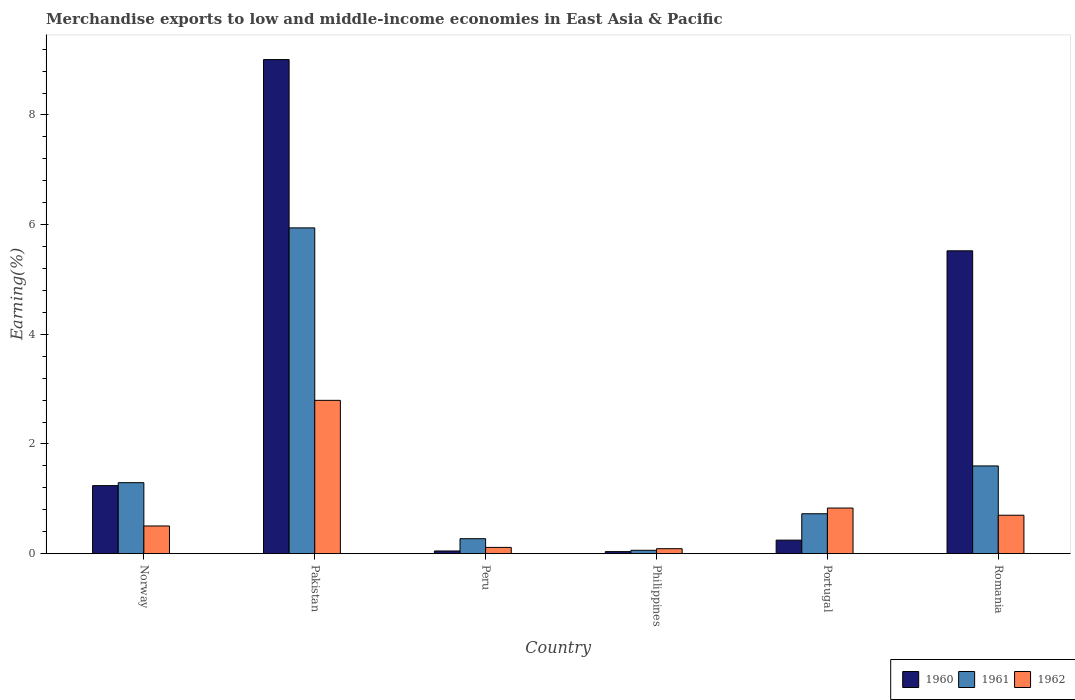How many different coloured bars are there?
Offer a terse response. 3. Are the number of bars per tick equal to the number of legend labels?
Your response must be concise. Yes. Are the number of bars on each tick of the X-axis equal?
Your answer should be very brief. Yes. What is the percentage of amount earned from merchandise exports in 1960 in Norway?
Provide a short and direct response. 1.24. Across all countries, what is the maximum percentage of amount earned from merchandise exports in 1961?
Offer a terse response. 5.94. Across all countries, what is the minimum percentage of amount earned from merchandise exports in 1960?
Keep it short and to the point. 0.04. What is the total percentage of amount earned from merchandise exports in 1961 in the graph?
Ensure brevity in your answer.  9.9. What is the difference between the percentage of amount earned from merchandise exports in 1960 in Norway and that in Portugal?
Make the answer very short. 0.99. What is the difference between the percentage of amount earned from merchandise exports in 1962 in Norway and the percentage of amount earned from merchandise exports in 1960 in Pakistan?
Your response must be concise. -8.5. What is the average percentage of amount earned from merchandise exports in 1961 per country?
Your answer should be compact. 1.65. What is the difference between the percentage of amount earned from merchandise exports of/in 1960 and percentage of amount earned from merchandise exports of/in 1961 in Pakistan?
Your answer should be very brief. 3.07. In how many countries, is the percentage of amount earned from merchandise exports in 1962 greater than 3.6 %?
Your answer should be compact. 0. What is the ratio of the percentage of amount earned from merchandise exports in 1961 in Pakistan to that in Philippines?
Your answer should be very brief. 96.53. Is the percentage of amount earned from merchandise exports in 1961 in Norway less than that in Portugal?
Keep it short and to the point. No. What is the difference between the highest and the second highest percentage of amount earned from merchandise exports in 1960?
Ensure brevity in your answer.  3.49. What is the difference between the highest and the lowest percentage of amount earned from merchandise exports in 1962?
Make the answer very short. 2.71. In how many countries, is the percentage of amount earned from merchandise exports in 1961 greater than the average percentage of amount earned from merchandise exports in 1961 taken over all countries?
Offer a very short reply. 1. What does the 2nd bar from the right in Romania represents?
Your response must be concise. 1961. How many bars are there?
Provide a short and direct response. 18. Are all the bars in the graph horizontal?
Ensure brevity in your answer.  No. What is the difference between two consecutive major ticks on the Y-axis?
Offer a terse response. 2. Are the values on the major ticks of Y-axis written in scientific E-notation?
Keep it short and to the point. No. Does the graph contain any zero values?
Provide a short and direct response. No. Does the graph contain grids?
Keep it short and to the point. No. How many legend labels are there?
Your response must be concise. 3. How are the legend labels stacked?
Your response must be concise. Horizontal. What is the title of the graph?
Your answer should be compact. Merchandise exports to low and middle-income economies in East Asia & Pacific. Does "1970" appear as one of the legend labels in the graph?
Your answer should be very brief. No. What is the label or title of the Y-axis?
Your response must be concise. Earning(%). What is the Earning(%) in 1960 in Norway?
Your answer should be very brief. 1.24. What is the Earning(%) in 1961 in Norway?
Ensure brevity in your answer.  1.29. What is the Earning(%) of 1962 in Norway?
Make the answer very short. 0.5. What is the Earning(%) in 1960 in Pakistan?
Offer a very short reply. 9.01. What is the Earning(%) of 1961 in Pakistan?
Offer a terse response. 5.94. What is the Earning(%) of 1962 in Pakistan?
Offer a terse response. 2.8. What is the Earning(%) in 1960 in Peru?
Make the answer very short. 0.05. What is the Earning(%) of 1961 in Peru?
Provide a succinct answer. 0.27. What is the Earning(%) in 1962 in Peru?
Ensure brevity in your answer.  0.11. What is the Earning(%) of 1960 in Philippines?
Provide a succinct answer. 0.04. What is the Earning(%) of 1961 in Philippines?
Offer a very short reply. 0.06. What is the Earning(%) in 1962 in Philippines?
Your response must be concise. 0.09. What is the Earning(%) in 1960 in Portugal?
Your response must be concise. 0.25. What is the Earning(%) in 1961 in Portugal?
Ensure brevity in your answer.  0.73. What is the Earning(%) in 1962 in Portugal?
Keep it short and to the point. 0.83. What is the Earning(%) of 1960 in Romania?
Provide a succinct answer. 5.52. What is the Earning(%) of 1961 in Romania?
Keep it short and to the point. 1.6. What is the Earning(%) in 1962 in Romania?
Your response must be concise. 0.7. Across all countries, what is the maximum Earning(%) of 1960?
Offer a terse response. 9.01. Across all countries, what is the maximum Earning(%) in 1961?
Offer a terse response. 5.94. Across all countries, what is the maximum Earning(%) in 1962?
Offer a very short reply. 2.8. Across all countries, what is the minimum Earning(%) in 1960?
Your answer should be very brief. 0.04. Across all countries, what is the minimum Earning(%) of 1961?
Provide a succinct answer. 0.06. Across all countries, what is the minimum Earning(%) in 1962?
Your answer should be very brief. 0.09. What is the total Earning(%) in 1960 in the graph?
Offer a very short reply. 16.11. What is the total Earning(%) of 1961 in the graph?
Ensure brevity in your answer.  9.9. What is the total Earning(%) of 1962 in the graph?
Keep it short and to the point. 5.04. What is the difference between the Earning(%) in 1960 in Norway and that in Pakistan?
Ensure brevity in your answer.  -7.77. What is the difference between the Earning(%) in 1961 in Norway and that in Pakistan?
Keep it short and to the point. -4.65. What is the difference between the Earning(%) of 1962 in Norway and that in Pakistan?
Offer a terse response. -2.29. What is the difference between the Earning(%) in 1960 in Norway and that in Peru?
Keep it short and to the point. 1.19. What is the difference between the Earning(%) in 1961 in Norway and that in Peru?
Offer a terse response. 1.02. What is the difference between the Earning(%) in 1962 in Norway and that in Peru?
Provide a succinct answer. 0.39. What is the difference between the Earning(%) of 1960 in Norway and that in Philippines?
Your answer should be very brief. 1.2. What is the difference between the Earning(%) of 1961 in Norway and that in Philippines?
Your response must be concise. 1.23. What is the difference between the Earning(%) in 1962 in Norway and that in Philippines?
Your response must be concise. 0.41. What is the difference between the Earning(%) of 1961 in Norway and that in Portugal?
Ensure brevity in your answer.  0.57. What is the difference between the Earning(%) of 1962 in Norway and that in Portugal?
Offer a very short reply. -0.33. What is the difference between the Earning(%) of 1960 in Norway and that in Romania?
Give a very brief answer. -4.28. What is the difference between the Earning(%) in 1961 in Norway and that in Romania?
Provide a short and direct response. -0.31. What is the difference between the Earning(%) in 1962 in Norway and that in Romania?
Your answer should be compact. -0.2. What is the difference between the Earning(%) of 1960 in Pakistan and that in Peru?
Give a very brief answer. 8.96. What is the difference between the Earning(%) of 1961 in Pakistan and that in Peru?
Offer a very short reply. 5.67. What is the difference between the Earning(%) in 1962 in Pakistan and that in Peru?
Ensure brevity in your answer.  2.68. What is the difference between the Earning(%) of 1960 in Pakistan and that in Philippines?
Offer a very short reply. 8.97. What is the difference between the Earning(%) in 1961 in Pakistan and that in Philippines?
Your answer should be compact. 5.88. What is the difference between the Earning(%) in 1962 in Pakistan and that in Philippines?
Your answer should be very brief. 2.71. What is the difference between the Earning(%) of 1960 in Pakistan and that in Portugal?
Provide a short and direct response. 8.76. What is the difference between the Earning(%) of 1961 in Pakistan and that in Portugal?
Keep it short and to the point. 5.21. What is the difference between the Earning(%) in 1962 in Pakistan and that in Portugal?
Ensure brevity in your answer.  1.96. What is the difference between the Earning(%) of 1960 in Pakistan and that in Romania?
Make the answer very short. 3.49. What is the difference between the Earning(%) in 1961 in Pakistan and that in Romania?
Your answer should be compact. 4.34. What is the difference between the Earning(%) in 1962 in Pakistan and that in Romania?
Your response must be concise. 2.09. What is the difference between the Earning(%) in 1960 in Peru and that in Philippines?
Make the answer very short. 0.01. What is the difference between the Earning(%) of 1961 in Peru and that in Philippines?
Your answer should be very brief. 0.21. What is the difference between the Earning(%) in 1962 in Peru and that in Philippines?
Ensure brevity in your answer.  0.02. What is the difference between the Earning(%) of 1960 in Peru and that in Portugal?
Your response must be concise. -0.2. What is the difference between the Earning(%) of 1961 in Peru and that in Portugal?
Offer a very short reply. -0.45. What is the difference between the Earning(%) in 1962 in Peru and that in Portugal?
Make the answer very short. -0.72. What is the difference between the Earning(%) in 1960 in Peru and that in Romania?
Offer a terse response. -5.47. What is the difference between the Earning(%) of 1961 in Peru and that in Romania?
Your answer should be compact. -1.33. What is the difference between the Earning(%) in 1962 in Peru and that in Romania?
Provide a short and direct response. -0.59. What is the difference between the Earning(%) in 1960 in Philippines and that in Portugal?
Make the answer very short. -0.21. What is the difference between the Earning(%) of 1961 in Philippines and that in Portugal?
Ensure brevity in your answer.  -0.67. What is the difference between the Earning(%) of 1962 in Philippines and that in Portugal?
Give a very brief answer. -0.74. What is the difference between the Earning(%) in 1960 in Philippines and that in Romania?
Give a very brief answer. -5.49. What is the difference between the Earning(%) in 1961 in Philippines and that in Romania?
Give a very brief answer. -1.54. What is the difference between the Earning(%) in 1962 in Philippines and that in Romania?
Your answer should be very brief. -0.61. What is the difference between the Earning(%) in 1960 in Portugal and that in Romania?
Make the answer very short. -5.28. What is the difference between the Earning(%) of 1961 in Portugal and that in Romania?
Your answer should be very brief. -0.87. What is the difference between the Earning(%) in 1962 in Portugal and that in Romania?
Make the answer very short. 0.13. What is the difference between the Earning(%) of 1960 in Norway and the Earning(%) of 1962 in Pakistan?
Give a very brief answer. -1.56. What is the difference between the Earning(%) of 1961 in Norway and the Earning(%) of 1962 in Pakistan?
Provide a succinct answer. -1.5. What is the difference between the Earning(%) in 1960 in Norway and the Earning(%) in 1962 in Peru?
Offer a very short reply. 1.13. What is the difference between the Earning(%) of 1961 in Norway and the Earning(%) of 1962 in Peru?
Make the answer very short. 1.18. What is the difference between the Earning(%) of 1960 in Norway and the Earning(%) of 1961 in Philippines?
Give a very brief answer. 1.18. What is the difference between the Earning(%) in 1960 in Norway and the Earning(%) in 1962 in Philippines?
Your answer should be very brief. 1.15. What is the difference between the Earning(%) of 1961 in Norway and the Earning(%) of 1962 in Philippines?
Offer a terse response. 1.2. What is the difference between the Earning(%) of 1960 in Norway and the Earning(%) of 1961 in Portugal?
Give a very brief answer. 0.51. What is the difference between the Earning(%) in 1960 in Norway and the Earning(%) in 1962 in Portugal?
Keep it short and to the point. 0.41. What is the difference between the Earning(%) in 1961 in Norway and the Earning(%) in 1962 in Portugal?
Your answer should be compact. 0.46. What is the difference between the Earning(%) in 1960 in Norway and the Earning(%) in 1961 in Romania?
Offer a terse response. -0.36. What is the difference between the Earning(%) of 1960 in Norway and the Earning(%) of 1962 in Romania?
Provide a succinct answer. 0.54. What is the difference between the Earning(%) in 1961 in Norway and the Earning(%) in 1962 in Romania?
Provide a short and direct response. 0.59. What is the difference between the Earning(%) in 1960 in Pakistan and the Earning(%) in 1961 in Peru?
Keep it short and to the point. 8.74. What is the difference between the Earning(%) in 1960 in Pakistan and the Earning(%) in 1962 in Peru?
Keep it short and to the point. 8.9. What is the difference between the Earning(%) of 1961 in Pakistan and the Earning(%) of 1962 in Peru?
Offer a very short reply. 5.83. What is the difference between the Earning(%) of 1960 in Pakistan and the Earning(%) of 1961 in Philippines?
Provide a succinct answer. 8.95. What is the difference between the Earning(%) in 1960 in Pakistan and the Earning(%) in 1962 in Philippines?
Provide a short and direct response. 8.92. What is the difference between the Earning(%) of 1961 in Pakistan and the Earning(%) of 1962 in Philippines?
Offer a terse response. 5.85. What is the difference between the Earning(%) in 1960 in Pakistan and the Earning(%) in 1961 in Portugal?
Your answer should be very brief. 8.28. What is the difference between the Earning(%) in 1960 in Pakistan and the Earning(%) in 1962 in Portugal?
Offer a terse response. 8.18. What is the difference between the Earning(%) of 1961 in Pakistan and the Earning(%) of 1962 in Portugal?
Offer a terse response. 5.11. What is the difference between the Earning(%) of 1960 in Pakistan and the Earning(%) of 1961 in Romania?
Your answer should be very brief. 7.41. What is the difference between the Earning(%) in 1960 in Pakistan and the Earning(%) in 1962 in Romania?
Offer a terse response. 8.31. What is the difference between the Earning(%) in 1961 in Pakistan and the Earning(%) in 1962 in Romania?
Your response must be concise. 5.24. What is the difference between the Earning(%) in 1960 in Peru and the Earning(%) in 1961 in Philippines?
Keep it short and to the point. -0.01. What is the difference between the Earning(%) of 1960 in Peru and the Earning(%) of 1962 in Philippines?
Provide a succinct answer. -0.04. What is the difference between the Earning(%) in 1961 in Peru and the Earning(%) in 1962 in Philippines?
Offer a very short reply. 0.18. What is the difference between the Earning(%) in 1960 in Peru and the Earning(%) in 1961 in Portugal?
Make the answer very short. -0.68. What is the difference between the Earning(%) in 1960 in Peru and the Earning(%) in 1962 in Portugal?
Offer a terse response. -0.78. What is the difference between the Earning(%) of 1961 in Peru and the Earning(%) of 1962 in Portugal?
Keep it short and to the point. -0.56. What is the difference between the Earning(%) in 1960 in Peru and the Earning(%) in 1961 in Romania?
Keep it short and to the point. -1.55. What is the difference between the Earning(%) of 1960 in Peru and the Earning(%) of 1962 in Romania?
Your answer should be very brief. -0.65. What is the difference between the Earning(%) of 1961 in Peru and the Earning(%) of 1962 in Romania?
Offer a terse response. -0.43. What is the difference between the Earning(%) in 1960 in Philippines and the Earning(%) in 1961 in Portugal?
Provide a succinct answer. -0.69. What is the difference between the Earning(%) of 1960 in Philippines and the Earning(%) of 1962 in Portugal?
Offer a terse response. -0.79. What is the difference between the Earning(%) in 1961 in Philippines and the Earning(%) in 1962 in Portugal?
Provide a short and direct response. -0.77. What is the difference between the Earning(%) in 1960 in Philippines and the Earning(%) in 1961 in Romania?
Keep it short and to the point. -1.56. What is the difference between the Earning(%) in 1960 in Philippines and the Earning(%) in 1962 in Romania?
Make the answer very short. -0.66. What is the difference between the Earning(%) in 1961 in Philippines and the Earning(%) in 1962 in Romania?
Ensure brevity in your answer.  -0.64. What is the difference between the Earning(%) of 1960 in Portugal and the Earning(%) of 1961 in Romania?
Your response must be concise. -1.35. What is the difference between the Earning(%) in 1960 in Portugal and the Earning(%) in 1962 in Romania?
Offer a very short reply. -0.45. What is the difference between the Earning(%) of 1961 in Portugal and the Earning(%) of 1962 in Romania?
Your response must be concise. 0.03. What is the average Earning(%) in 1960 per country?
Give a very brief answer. 2.68. What is the average Earning(%) of 1961 per country?
Keep it short and to the point. 1.65. What is the average Earning(%) of 1962 per country?
Your answer should be compact. 0.84. What is the difference between the Earning(%) of 1960 and Earning(%) of 1961 in Norway?
Ensure brevity in your answer.  -0.05. What is the difference between the Earning(%) of 1960 and Earning(%) of 1962 in Norway?
Give a very brief answer. 0.74. What is the difference between the Earning(%) in 1961 and Earning(%) in 1962 in Norway?
Provide a short and direct response. 0.79. What is the difference between the Earning(%) of 1960 and Earning(%) of 1961 in Pakistan?
Your answer should be compact. 3.07. What is the difference between the Earning(%) in 1960 and Earning(%) in 1962 in Pakistan?
Provide a short and direct response. 6.21. What is the difference between the Earning(%) of 1961 and Earning(%) of 1962 in Pakistan?
Your answer should be very brief. 3.14. What is the difference between the Earning(%) in 1960 and Earning(%) in 1961 in Peru?
Your response must be concise. -0.22. What is the difference between the Earning(%) of 1960 and Earning(%) of 1962 in Peru?
Your answer should be compact. -0.07. What is the difference between the Earning(%) of 1961 and Earning(%) of 1962 in Peru?
Offer a very short reply. 0.16. What is the difference between the Earning(%) of 1960 and Earning(%) of 1961 in Philippines?
Make the answer very short. -0.02. What is the difference between the Earning(%) in 1960 and Earning(%) in 1962 in Philippines?
Provide a short and direct response. -0.05. What is the difference between the Earning(%) in 1961 and Earning(%) in 1962 in Philippines?
Your answer should be very brief. -0.03. What is the difference between the Earning(%) in 1960 and Earning(%) in 1961 in Portugal?
Offer a terse response. -0.48. What is the difference between the Earning(%) in 1960 and Earning(%) in 1962 in Portugal?
Make the answer very short. -0.58. What is the difference between the Earning(%) in 1961 and Earning(%) in 1962 in Portugal?
Offer a very short reply. -0.1. What is the difference between the Earning(%) in 1960 and Earning(%) in 1961 in Romania?
Offer a very short reply. 3.92. What is the difference between the Earning(%) of 1960 and Earning(%) of 1962 in Romania?
Give a very brief answer. 4.82. What is the difference between the Earning(%) of 1961 and Earning(%) of 1962 in Romania?
Your answer should be compact. 0.9. What is the ratio of the Earning(%) of 1960 in Norway to that in Pakistan?
Offer a very short reply. 0.14. What is the ratio of the Earning(%) of 1961 in Norway to that in Pakistan?
Provide a succinct answer. 0.22. What is the ratio of the Earning(%) of 1962 in Norway to that in Pakistan?
Keep it short and to the point. 0.18. What is the ratio of the Earning(%) of 1960 in Norway to that in Peru?
Give a very brief answer. 25.36. What is the ratio of the Earning(%) of 1961 in Norway to that in Peru?
Keep it short and to the point. 4.74. What is the ratio of the Earning(%) in 1962 in Norway to that in Peru?
Make the answer very short. 4.42. What is the ratio of the Earning(%) in 1960 in Norway to that in Philippines?
Provide a succinct answer. 33.31. What is the ratio of the Earning(%) in 1961 in Norway to that in Philippines?
Give a very brief answer. 21.03. What is the ratio of the Earning(%) of 1962 in Norway to that in Philippines?
Give a very brief answer. 5.59. What is the ratio of the Earning(%) in 1960 in Norway to that in Portugal?
Your answer should be compact. 5.03. What is the ratio of the Earning(%) of 1961 in Norway to that in Portugal?
Provide a short and direct response. 1.78. What is the ratio of the Earning(%) in 1962 in Norway to that in Portugal?
Your answer should be compact. 0.61. What is the ratio of the Earning(%) of 1960 in Norway to that in Romania?
Your answer should be very brief. 0.22. What is the ratio of the Earning(%) of 1961 in Norway to that in Romania?
Offer a very short reply. 0.81. What is the ratio of the Earning(%) of 1962 in Norway to that in Romania?
Give a very brief answer. 0.72. What is the ratio of the Earning(%) of 1960 in Pakistan to that in Peru?
Provide a succinct answer. 184.16. What is the ratio of the Earning(%) in 1961 in Pakistan to that in Peru?
Offer a very short reply. 21.77. What is the ratio of the Earning(%) in 1962 in Pakistan to that in Peru?
Provide a short and direct response. 24.5. What is the ratio of the Earning(%) of 1960 in Pakistan to that in Philippines?
Your response must be concise. 241.91. What is the ratio of the Earning(%) of 1961 in Pakistan to that in Philippines?
Your answer should be compact. 96.53. What is the ratio of the Earning(%) of 1962 in Pakistan to that in Philippines?
Your response must be concise. 30.93. What is the ratio of the Earning(%) of 1960 in Pakistan to that in Portugal?
Your response must be concise. 36.51. What is the ratio of the Earning(%) of 1961 in Pakistan to that in Portugal?
Provide a short and direct response. 8.16. What is the ratio of the Earning(%) in 1962 in Pakistan to that in Portugal?
Offer a very short reply. 3.36. What is the ratio of the Earning(%) of 1960 in Pakistan to that in Romania?
Your answer should be compact. 1.63. What is the ratio of the Earning(%) in 1961 in Pakistan to that in Romania?
Your answer should be very brief. 3.71. What is the ratio of the Earning(%) of 1962 in Pakistan to that in Romania?
Provide a succinct answer. 3.99. What is the ratio of the Earning(%) of 1960 in Peru to that in Philippines?
Your answer should be compact. 1.31. What is the ratio of the Earning(%) of 1961 in Peru to that in Philippines?
Offer a terse response. 4.44. What is the ratio of the Earning(%) in 1962 in Peru to that in Philippines?
Provide a short and direct response. 1.26. What is the ratio of the Earning(%) of 1960 in Peru to that in Portugal?
Offer a terse response. 0.2. What is the ratio of the Earning(%) in 1961 in Peru to that in Portugal?
Your answer should be compact. 0.38. What is the ratio of the Earning(%) of 1962 in Peru to that in Portugal?
Keep it short and to the point. 0.14. What is the ratio of the Earning(%) in 1960 in Peru to that in Romania?
Your answer should be compact. 0.01. What is the ratio of the Earning(%) of 1961 in Peru to that in Romania?
Offer a terse response. 0.17. What is the ratio of the Earning(%) in 1962 in Peru to that in Romania?
Offer a very short reply. 0.16. What is the ratio of the Earning(%) of 1960 in Philippines to that in Portugal?
Ensure brevity in your answer.  0.15. What is the ratio of the Earning(%) in 1961 in Philippines to that in Portugal?
Provide a short and direct response. 0.08. What is the ratio of the Earning(%) in 1962 in Philippines to that in Portugal?
Provide a short and direct response. 0.11. What is the ratio of the Earning(%) of 1960 in Philippines to that in Romania?
Offer a terse response. 0.01. What is the ratio of the Earning(%) in 1961 in Philippines to that in Romania?
Ensure brevity in your answer.  0.04. What is the ratio of the Earning(%) in 1962 in Philippines to that in Romania?
Your answer should be compact. 0.13. What is the ratio of the Earning(%) of 1960 in Portugal to that in Romania?
Give a very brief answer. 0.04. What is the ratio of the Earning(%) in 1961 in Portugal to that in Romania?
Give a very brief answer. 0.45. What is the ratio of the Earning(%) of 1962 in Portugal to that in Romania?
Provide a succinct answer. 1.19. What is the difference between the highest and the second highest Earning(%) in 1960?
Your answer should be very brief. 3.49. What is the difference between the highest and the second highest Earning(%) of 1961?
Provide a short and direct response. 4.34. What is the difference between the highest and the second highest Earning(%) in 1962?
Ensure brevity in your answer.  1.96. What is the difference between the highest and the lowest Earning(%) in 1960?
Offer a terse response. 8.97. What is the difference between the highest and the lowest Earning(%) in 1961?
Give a very brief answer. 5.88. What is the difference between the highest and the lowest Earning(%) of 1962?
Provide a succinct answer. 2.71. 